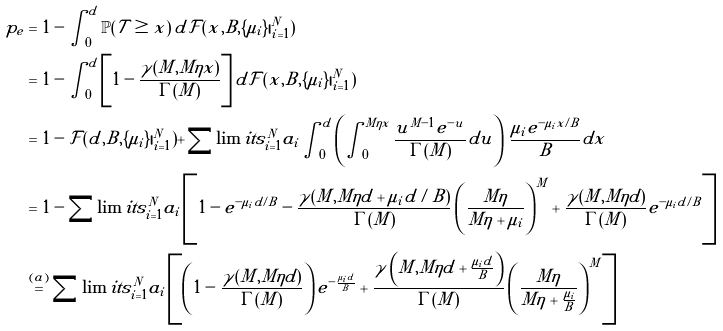<formula> <loc_0><loc_0><loc_500><loc_500>p _ { e } & = 1 - \int _ { 0 } ^ { d } \mathbb { P } ( \mathcal { T } \geq x ) \, d \mathcal { F } ( x , B , \{ \mu _ { i } \} | _ { i = 1 } ^ { N } ) \\ & = 1 - \int _ { 0 } ^ { d } \left [ 1 - \frac { \gamma ( M , M \eta x ) } { \Gamma ( M ) } \right ] d \mathcal { F } ( x , B , \{ \mu _ { i } \} | _ { i = 1 } ^ { N } ) \\ & = 1 - \mathcal { F } ( d , B , \{ \mu _ { i } \} | _ { i = 1 } ^ { N } ) + \sum \lim i t s _ { i = 1 } ^ { N } a _ { i } \int _ { 0 } ^ { d } \left ( \int _ { 0 } ^ { M \eta x } \frac { u ^ { M - 1 } e ^ { - u } } { \Gamma ( M ) } d u \right ) \, \frac { \mu _ { i } e ^ { - \mu _ { i } x / B } } { B } d x \\ & = 1 - \sum \lim i t s _ { i = 1 } ^ { N } a _ { i } \left [ 1 - e ^ { - \mu _ { i } d / B } - \frac { \gamma ( M , M \eta d + \mu _ { i } d / B ) } { \Gamma ( M ) } \left ( \frac { M \eta } { M \eta + \mu _ { i } } \right ) ^ { M } + \frac { \gamma ( M , M \eta d ) } { \Gamma ( M ) } e ^ { - \mu _ { i } d / B } \right ] \\ & \stackrel { ( a ) } { = } \sum \lim i t s _ { i = 1 } ^ { N } a _ { i } \left [ \left ( 1 - \frac { \gamma ( M , M \eta d ) } { \Gamma ( M ) } \right ) e ^ { - \frac { \mu _ { i } d } { B } } + \frac { \gamma \left ( M , M \eta d + \frac { \mu _ { i } d } { B } \right ) } { \Gamma ( M ) } \left ( \frac { M \eta } { M \eta + \frac { \mu _ { i } } { B } } \right ) ^ { M } \right ]</formula> 